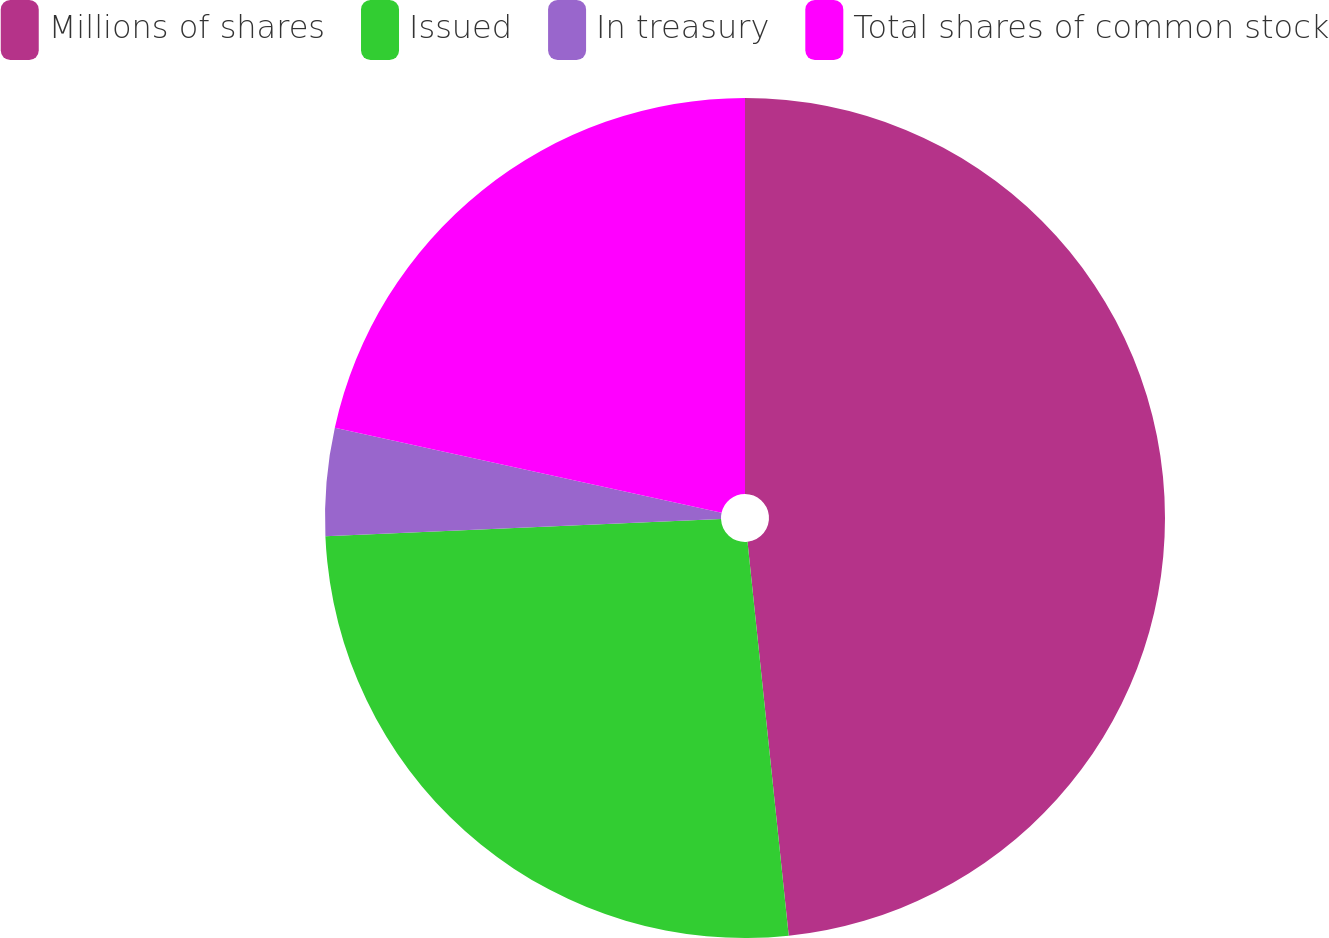<chart> <loc_0><loc_0><loc_500><loc_500><pie_chart><fcel>Millions of shares<fcel>Issued<fcel>In treasury<fcel>Total shares of common stock<nl><fcel>48.34%<fcel>25.97%<fcel>4.14%<fcel>21.55%<nl></chart> 